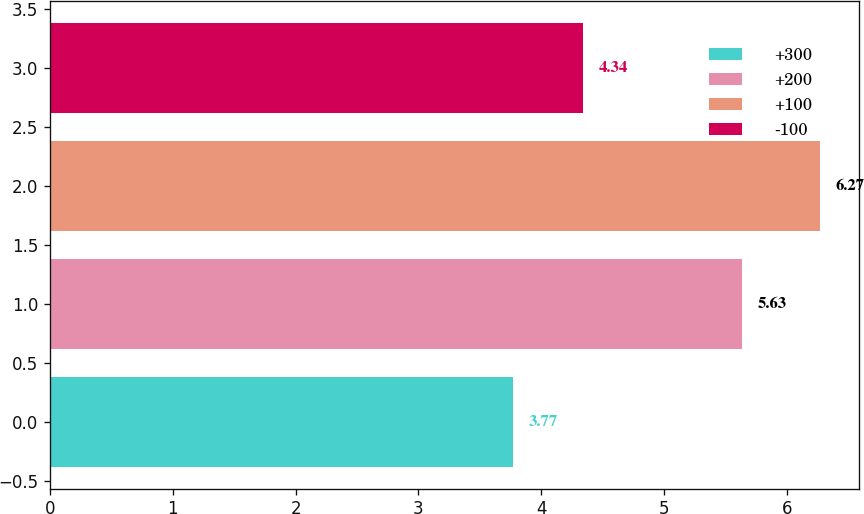Convert chart to OTSL. <chart><loc_0><loc_0><loc_500><loc_500><bar_chart><fcel>+300<fcel>+200<fcel>+100<fcel>-100<nl><fcel>3.77<fcel>5.63<fcel>6.27<fcel>4.34<nl></chart> 